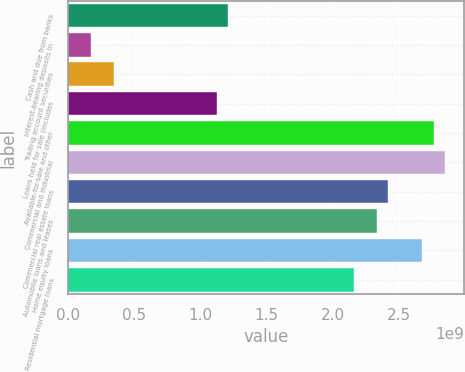Convert chart to OTSL. <chart><loc_0><loc_0><loc_500><loc_500><bar_chart><fcel>Cash and due from banks<fcel>Interest-bearing deposits in<fcel>Trading account securities<fcel>Loans held for sale (includes<fcel>Available-for-sale and other<fcel>Commercial and industrial<fcel>Commercial real estate loans<fcel>Automobile loans and leases<fcel>Home equity loans<fcel>Residential mortgage loans<nl><fcel>1.20987e+09<fcel>1.72846e+08<fcel>3.45683e+08<fcel>1.12345e+09<fcel>2.76541e+09<fcel>2.85182e+09<fcel>2.41973e+09<fcel>2.33331e+09<fcel>2.67899e+09<fcel>2.16048e+09<nl></chart> 